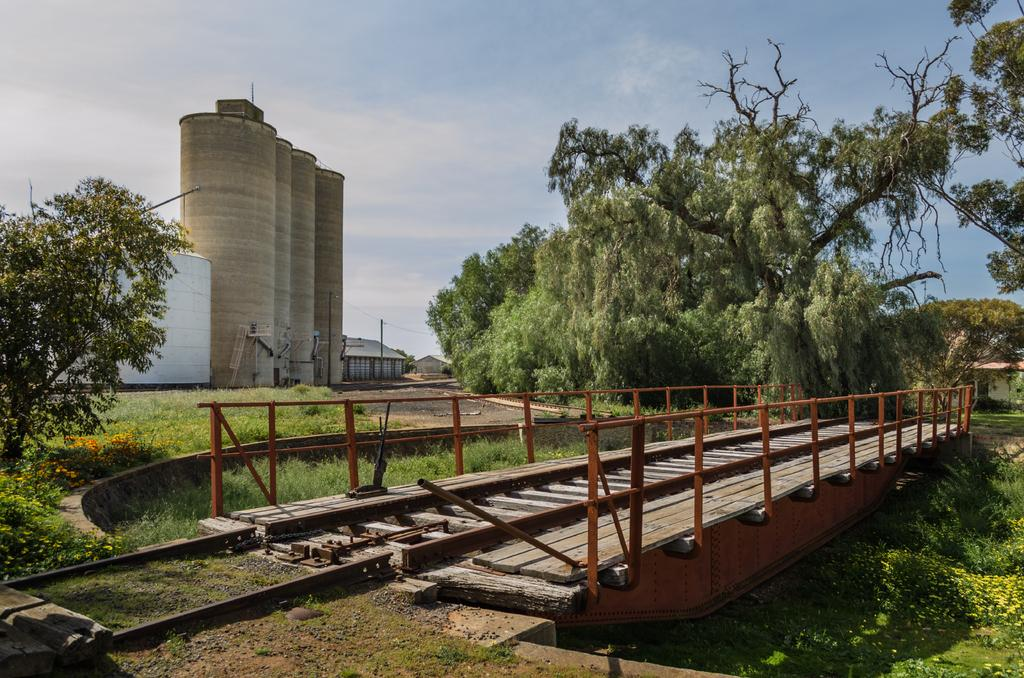What type of structure can be seen in the image? There is a bridge in the image. What type of vegetation is present in the image? There is grass, plants, flowers, and trees in the image. What can be seen in the background of the image? In the background, there are containers, a shed, poles, and the sky. What type of brick is used to build the bat's vest in the image? There is no brick, bat, or vest present in the image. 